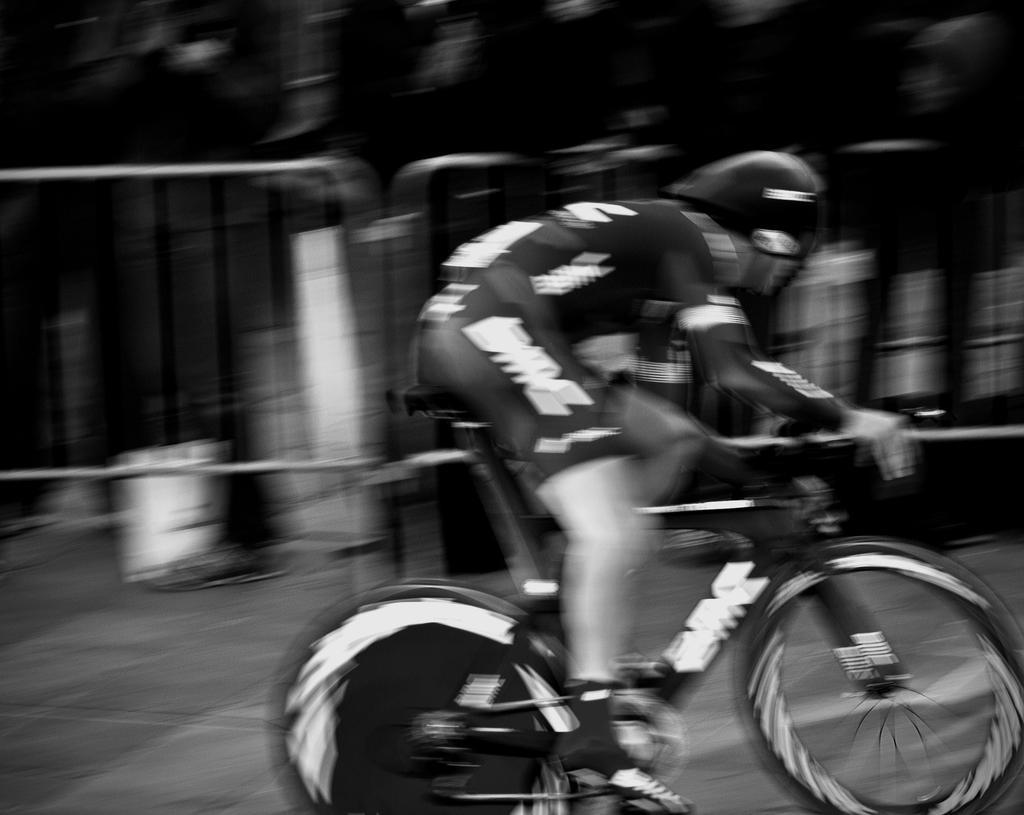Please provide a concise description of this image. Here we can see a person riding the bicycle behind him there are railing and group of people standing 